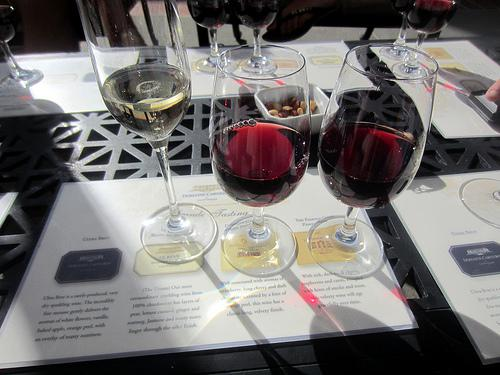Question: how many yellow squares are printed on the paper?
Choices:
A. 6.
B. 4.
C. 5.
D. 3.
Answer with the letter. Answer: D Question: how many purple square are printed on the paper?
Choices:
A. 0.
B. 2.
C. 3.
D. 1.
Answer with the letter. Answer: D 